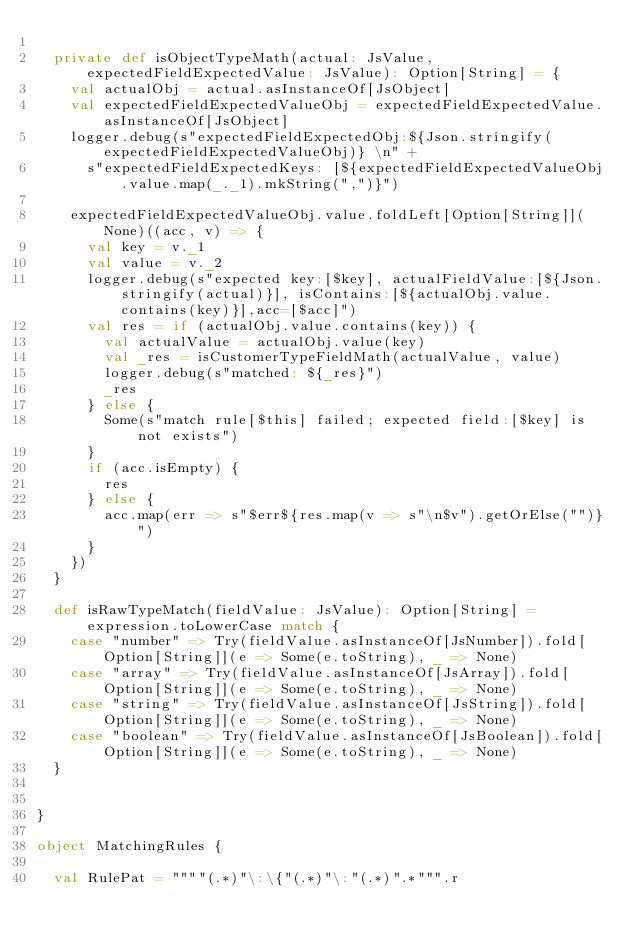<code> <loc_0><loc_0><loc_500><loc_500><_Scala_>
  private def isObjectTypeMath(actual: JsValue, expectedFieldExpectedValue: JsValue): Option[String] = {
    val actualObj = actual.asInstanceOf[JsObject]
    val expectedFieldExpectedValueObj = expectedFieldExpectedValue.asInstanceOf[JsObject]
    logger.debug(s"expectedFieldExpectedObj:${Json.stringify(expectedFieldExpectedValueObj)} \n" +
      s"expectedFieldExpectedKeys: [${expectedFieldExpectedValueObj.value.map(_._1).mkString(",")}")

    expectedFieldExpectedValueObj.value.foldLeft[Option[String]](None)((acc, v) => {
      val key = v._1
      val value = v._2
      logger.debug(s"expected key:[$key], actualFieldValue:[${Json.stringify(actual)}], isContains:[${actualObj.value.contains(key)}],acc=[$acc]")
      val res = if (actualObj.value.contains(key)) {
        val actualValue = actualObj.value(key)
        val _res = isCustomerTypeFieldMath(actualValue, value)
        logger.debug(s"matched: ${_res}")
        _res
      } else {
        Some(s"match rule[$this] failed; expected field:[$key] is not exists")
      }
      if (acc.isEmpty) {
        res
      } else {
        acc.map(err => s"$err${res.map(v => s"\n$v").getOrElse("")}")
      }
    })
  }

  def isRawTypeMatch(fieldValue: JsValue): Option[String] = expression.toLowerCase match {
    case "number" => Try(fieldValue.asInstanceOf[JsNumber]).fold[Option[String]](e => Some(e.toString), _ => None)
    case "array" => Try(fieldValue.asInstanceOf[JsArray]).fold[Option[String]](e => Some(e.toString), _ => None)
    case "string" => Try(fieldValue.asInstanceOf[JsString]).fold[Option[String]](e => Some(e.toString), _ => None)
    case "boolean" => Try(fieldValue.asInstanceOf[JsBoolean]).fold[Option[String]](e => Some(e.toString), _ => None)
  }


}

object MatchingRules {

  val RulePat = """"(.*)"\:\{"(.*)"\:"(.*)".*""".r</code> 